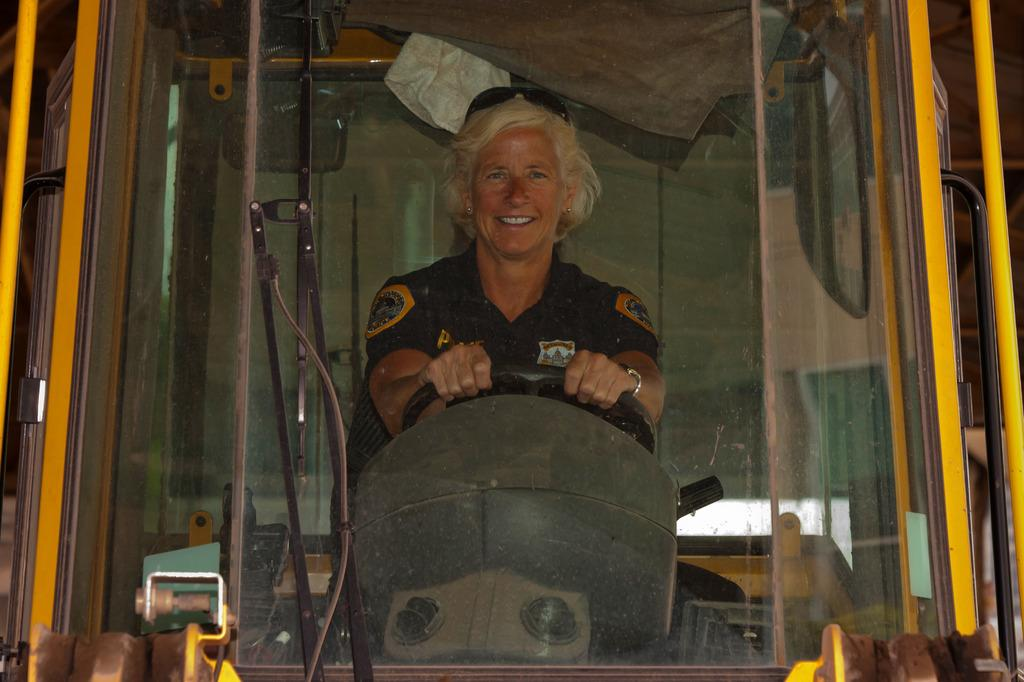Who is the main subject in the image? There is a woman in the image. What is the woman wearing? The woman is wearing a black dress. What is the woman doing in the image? The woman is riding a vehicle. What type of corn can be seen growing in the background of the image? There is no corn visible in the image; it features a woman riding a vehicle while wearing a black dress. 